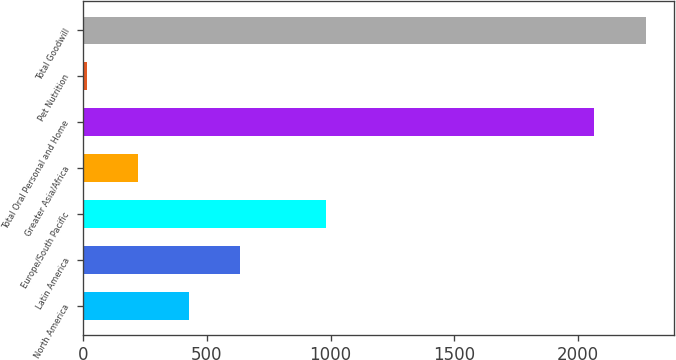Convert chart to OTSL. <chart><loc_0><loc_0><loc_500><loc_500><bar_chart><fcel>North America<fcel>Latin America<fcel>Europe/South Pacific<fcel>Greater Asia/Africa<fcel>Total Oral Personal and Home<fcel>Pet Nutrition<fcel>Total Goodwill<nl><fcel>428.36<fcel>635.04<fcel>980.2<fcel>221.68<fcel>2066.8<fcel>15<fcel>2273.48<nl></chart> 